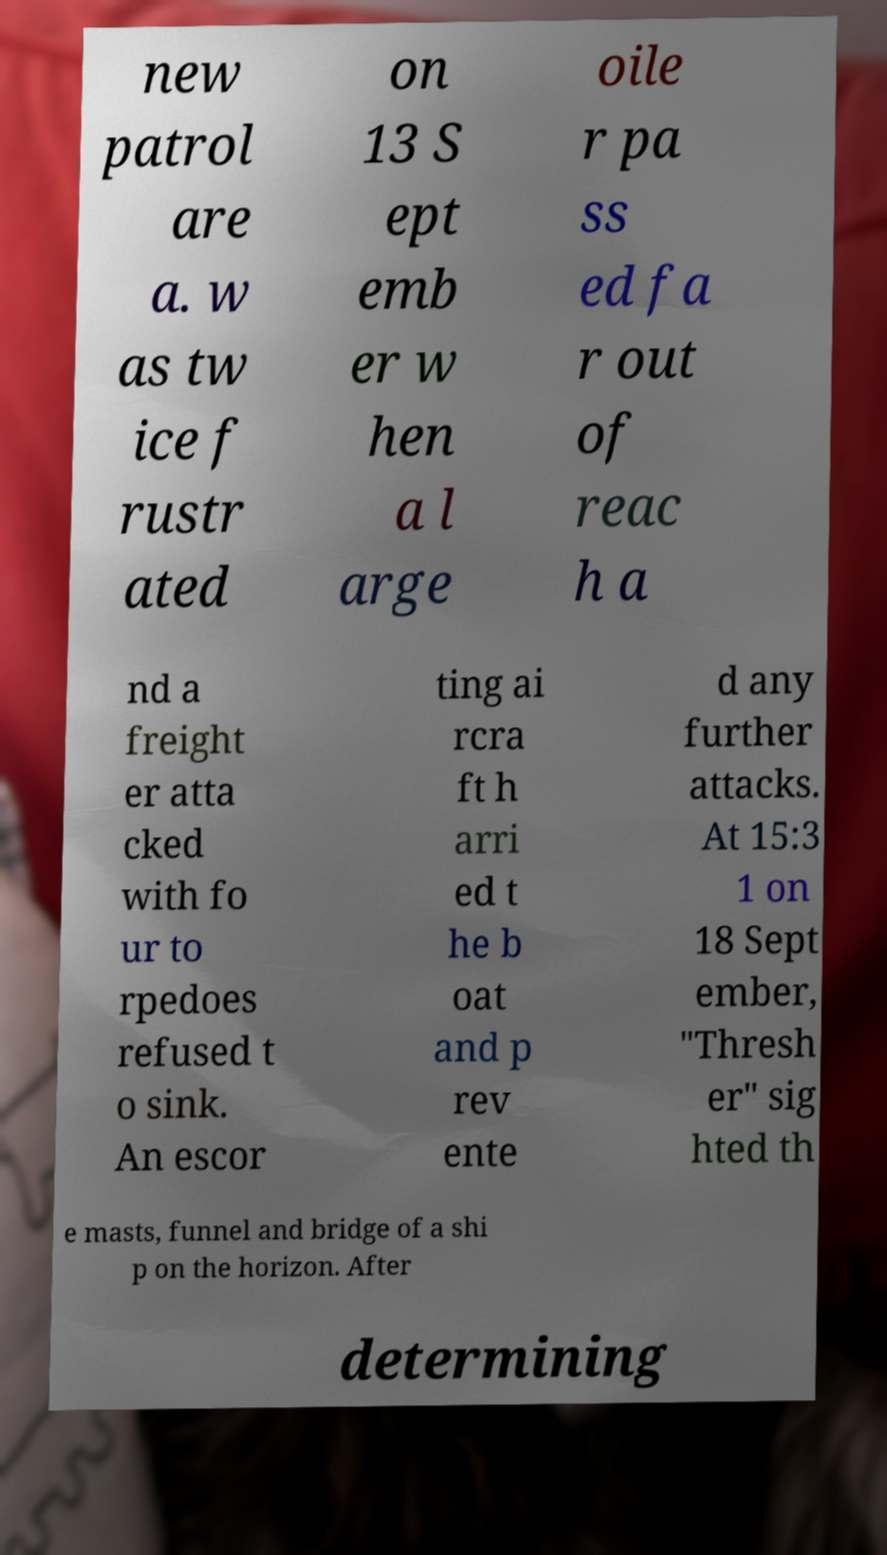Can you read and provide the text displayed in the image?This photo seems to have some interesting text. Can you extract and type it out for me? new patrol are a. w as tw ice f rustr ated on 13 S ept emb er w hen a l arge oile r pa ss ed fa r out of reac h a nd a freight er atta cked with fo ur to rpedoes refused t o sink. An escor ting ai rcra ft h arri ed t he b oat and p rev ente d any further attacks. At 15:3 1 on 18 Sept ember, "Thresh er" sig hted th e masts, funnel and bridge of a shi p on the horizon. After determining 